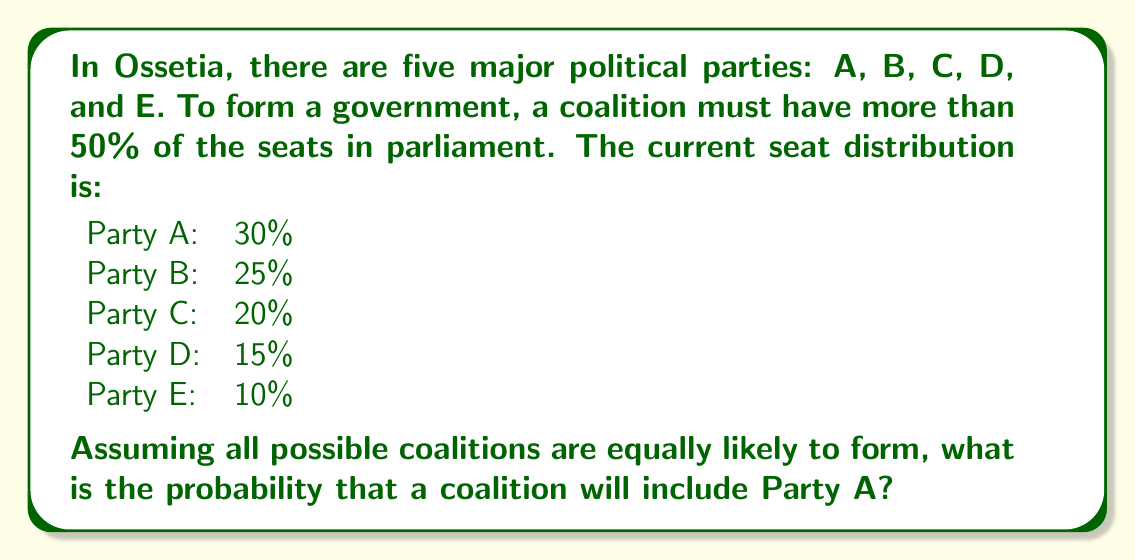Can you answer this question? To solve this problem, we need to follow these steps:

1. Calculate the total number of possible coalitions that can form a government (more than 50% of seats).
2. Calculate the number of these coalitions that include Party A.
3. Divide the number of coalitions including Party A by the total number of possible coalitions.

Step 1: Total number of possible coalitions
Let's list all coalitions that have more than 50% of seats:

- A + B = 55%
- A + C = 50% (not enough)
- A + D = 45% (not enough)
- A + E = 40% (not enough)
- B + C = 45% (not enough)
- B + D = 40% (not enough)
- B + E = 35% (not enough)
- C + D = 35% (not enough)
- C + E = 30% (not enough)
- D + E = 25% (not enough)
- A + B + C = 75%
- A + B + D = 70%
- A + B + E = 65%
- A + C + D = 65%
- A + C + E = 60%
- A + D + E = 55%
- B + C + D = 60%
- B + C + E = 55%
- A + B + C + D = 90%
- A + B + C + E = 85%
- A + B + D + E = 80%
- A + C + D + E = 75%
- B + C + D + E = 70%
- A + B + C + D + E = 100%

Total number of possible coalitions: 16

Step 2: Number of coalitions including Party A
Counting from the list above, there are 11 coalitions that include Party A.

Step 3: Calculate the probability
Probability = (Number of favorable outcomes) / (Total number of possible outcomes)

$$ P(\text{Coalition includes A}) = \frac{11}{16} = 0.6875 $$
Answer: The probability that a coalition will include Party A is $\frac{11}{16}$ or 0.6875 (68.75%). 